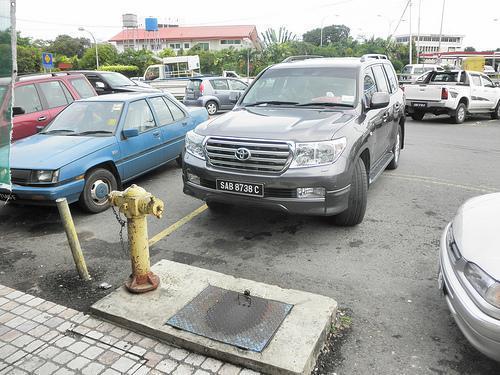How many hydrants are there?
Give a very brief answer. 1. How many yellow cars are there?
Give a very brief answer. 0. 